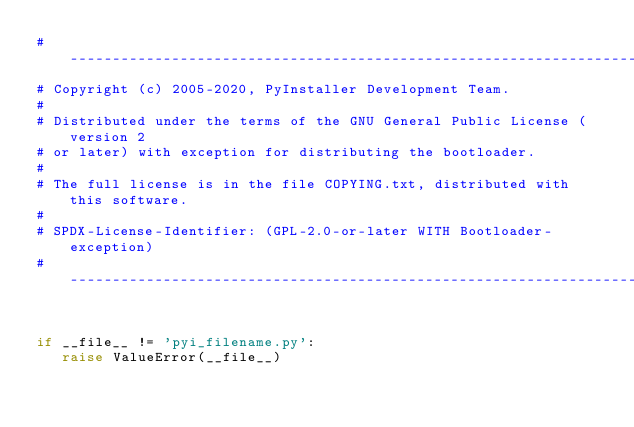Convert code to text. <code><loc_0><loc_0><loc_500><loc_500><_Python_>#-----------------------------------------------------------------------------
# Copyright (c) 2005-2020, PyInstaller Development Team.
#
# Distributed under the terms of the GNU General Public License (version 2
# or later) with exception for distributing the bootloader.
#
# The full license is in the file COPYING.txt, distributed with this software.
#
# SPDX-License-Identifier: (GPL-2.0-or-later WITH Bootloader-exception)
#-----------------------------------------------------------------------------


if __file__ != 'pyi_filename.py':
   raise ValueError(__file__)
</code> 